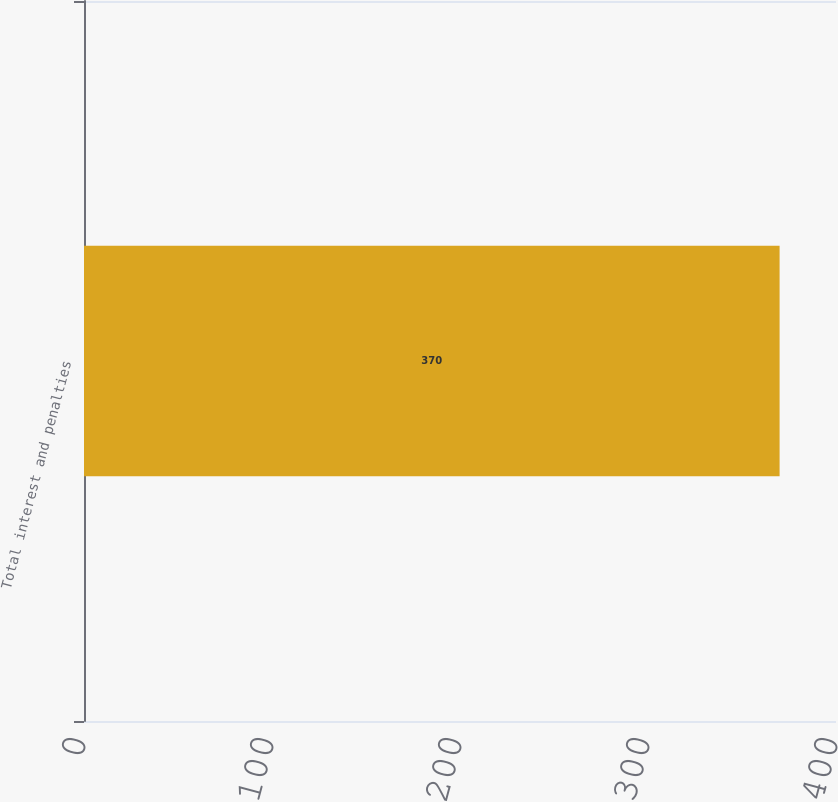Convert chart. <chart><loc_0><loc_0><loc_500><loc_500><bar_chart><fcel>Total interest and penalties<nl><fcel>370<nl></chart> 